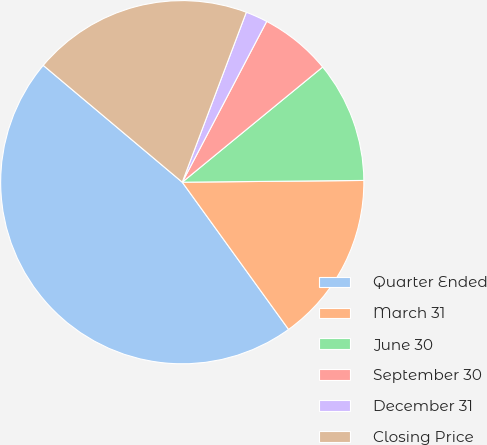Convert chart. <chart><loc_0><loc_0><loc_500><loc_500><pie_chart><fcel>Quarter Ended<fcel>March 31<fcel>June 30<fcel>September 30<fcel>December 31<fcel>Closing Price<nl><fcel>46.08%<fcel>15.2%<fcel>10.78%<fcel>6.37%<fcel>1.96%<fcel>19.61%<nl></chart> 